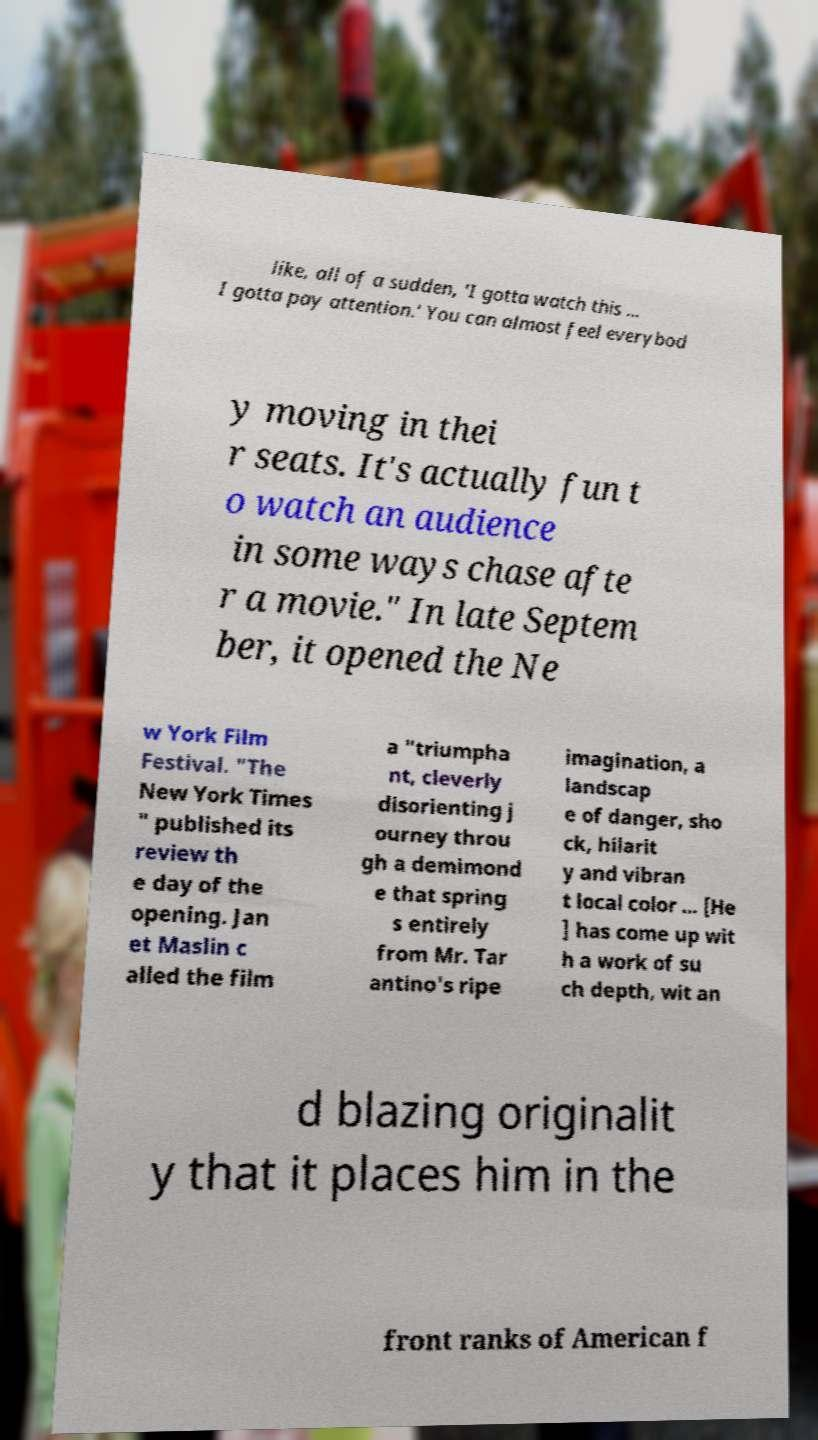For documentation purposes, I need the text within this image transcribed. Could you provide that? like, all of a sudden, 'I gotta watch this ... I gotta pay attention.' You can almost feel everybod y moving in thei r seats. It's actually fun t o watch an audience in some ways chase afte r a movie." In late Septem ber, it opened the Ne w York Film Festival. "The New York Times " published its review th e day of the opening. Jan et Maslin c alled the film a "triumpha nt, cleverly disorienting j ourney throu gh a demimond e that spring s entirely from Mr. Tar antino's ripe imagination, a landscap e of danger, sho ck, hilarit y and vibran t local color ... [He ] has come up wit h a work of su ch depth, wit an d blazing originalit y that it places him in the front ranks of American f 